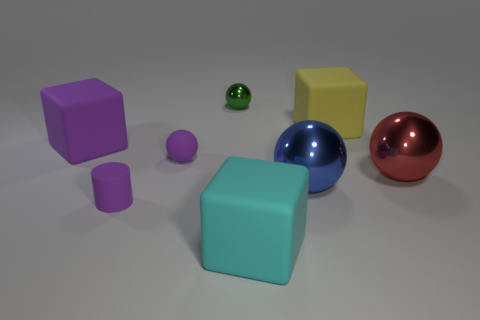There is a thing that is on the left side of the tiny green metallic object and right of the small purple matte cylinder; what color is it?
Offer a terse response. Purple. Are there any red metallic things that have the same shape as the blue metallic object?
Provide a succinct answer. Yes. Does the matte sphere have the same color as the tiny cylinder?
Provide a short and direct response. Yes. Is there a small purple rubber object that is left of the big cube in front of the blue object?
Your answer should be compact. Yes. What number of objects are either blocks left of the small purple matte cylinder or balls in front of the purple matte sphere?
Provide a short and direct response. 3. How many things are either large shiny balls or large things behind the cyan cube?
Give a very brief answer. 4. There is a matte cube that is in front of the tiny matte object that is behind the small purple thing that is in front of the big blue shiny sphere; what size is it?
Give a very brief answer. Large. There is a cyan thing that is the same size as the blue metal object; what is its material?
Keep it short and to the point. Rubber. Are there any purple cylinders of the same size as the yellow rubber thing?
Offer a very short reply. No. There is a thing that is left of the cylinder; does it have the same size as the big cyan rubber block?
Your response must be concise. Yes. 